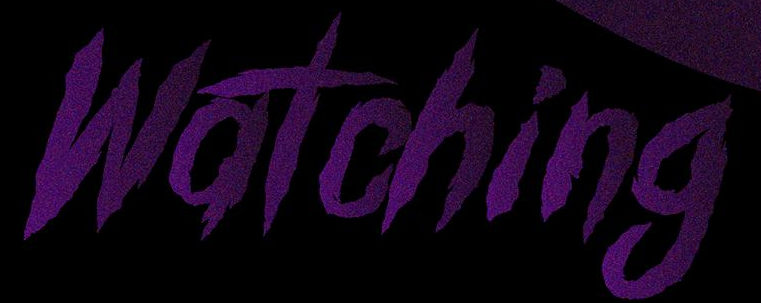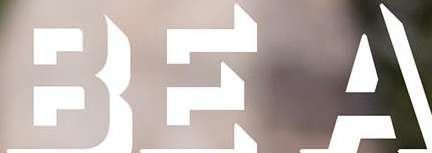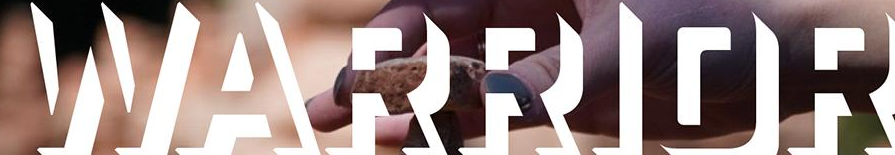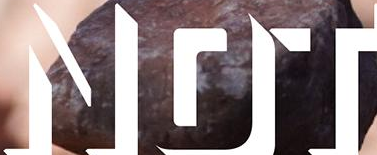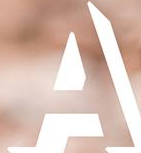Read the text content from these images in order, separated by a semicolon. Watching; BEA; WARRIOR; NOT; A 